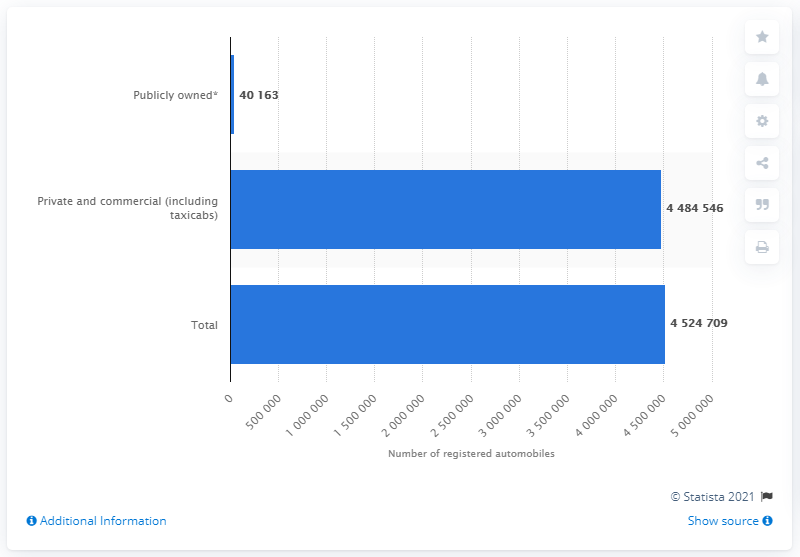Point out several critical features in this image. In the year 2016, a total of 4,484,546 private and commercial automobiles were registered in the state of Illinois. 